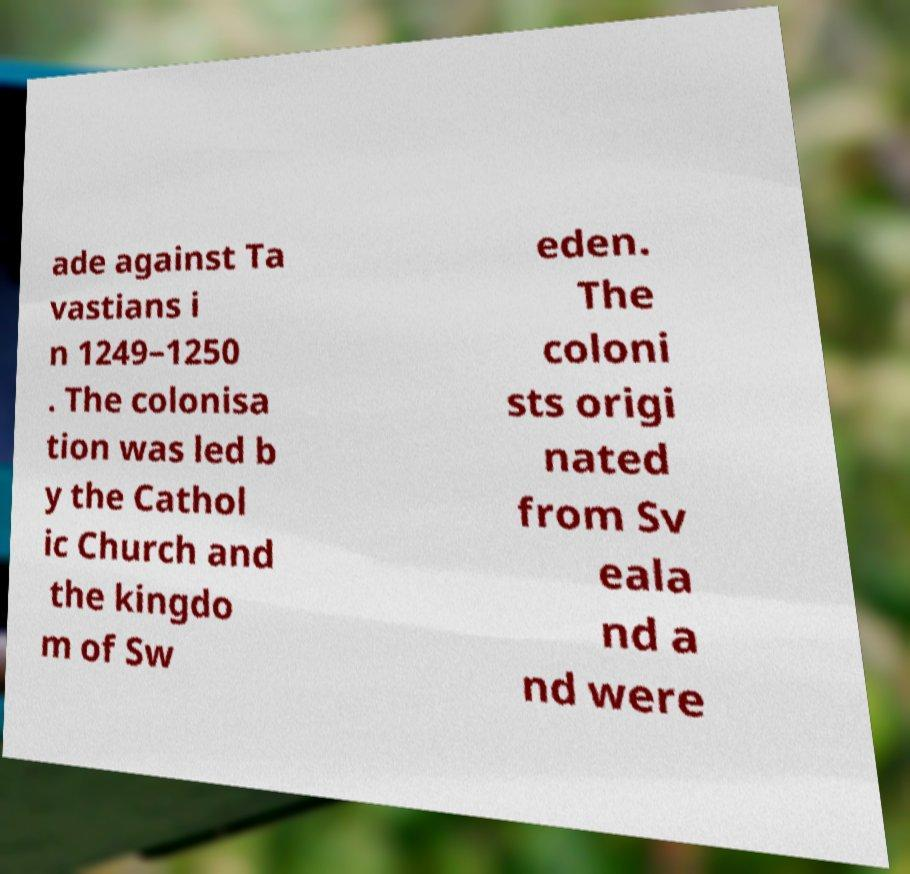For documentation purposes, I need the text within this image transcribed. Could you provide that? ade against Ta vastians i n 1249–1250 . The colonisa tion was led b y the Cathol ic Church and the kingdo m of Sw eden. The coloni sts origi nated from Sv eala nd a nd were 